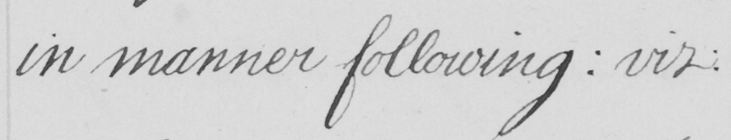Can you tell me what this handwritten text says? in manner following :  viz : 